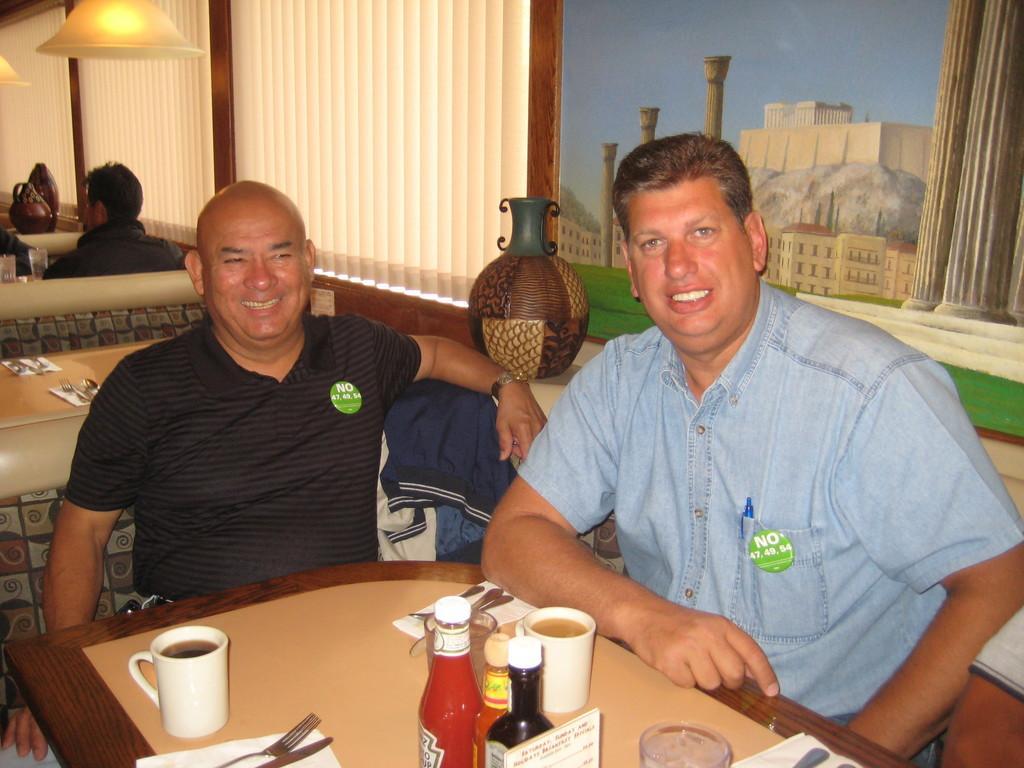In one or two sentences, can you explain what this image depicts? In this picture we can see two men sitting on chair and smiling and in front of them on table we have bottles, cup with drink in it, spoons, tissue paper, fork, knife and in background we can see wall, banner, lamp, some more persons. 